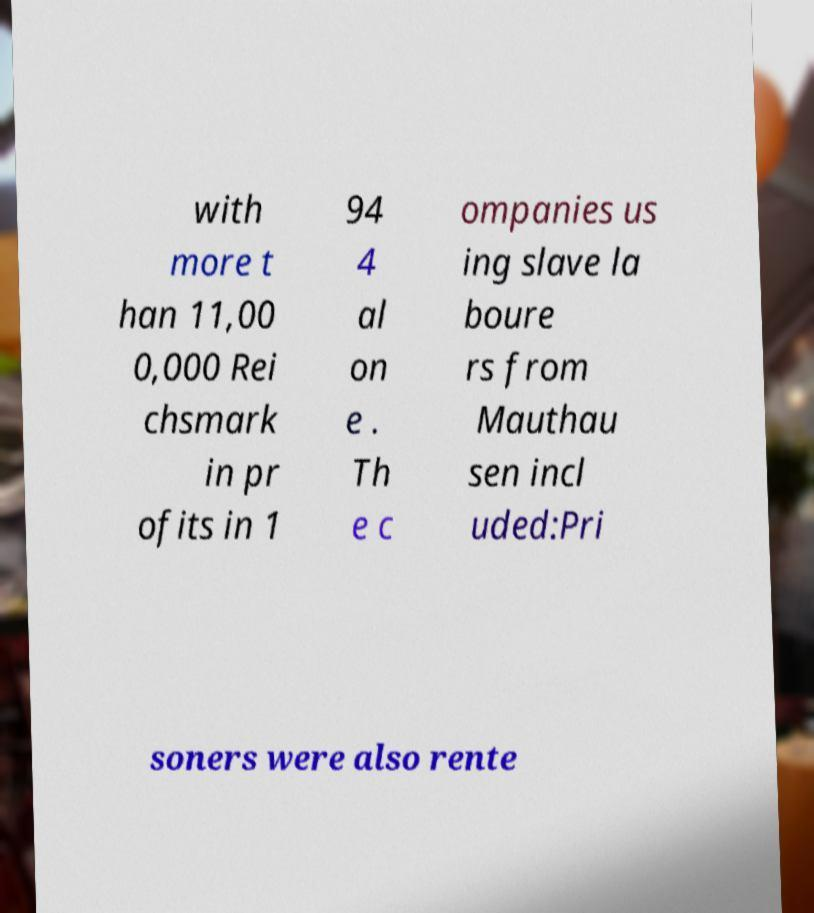Please identify and transcribe the text found in this image. with more t han 11,00 0,000 Rei chsmark in pr ofits in 1 94 4 al on e . Th e c ompanies us ing slave la boure rs from Mauthau sen incl uded:Pri soners were also rente 